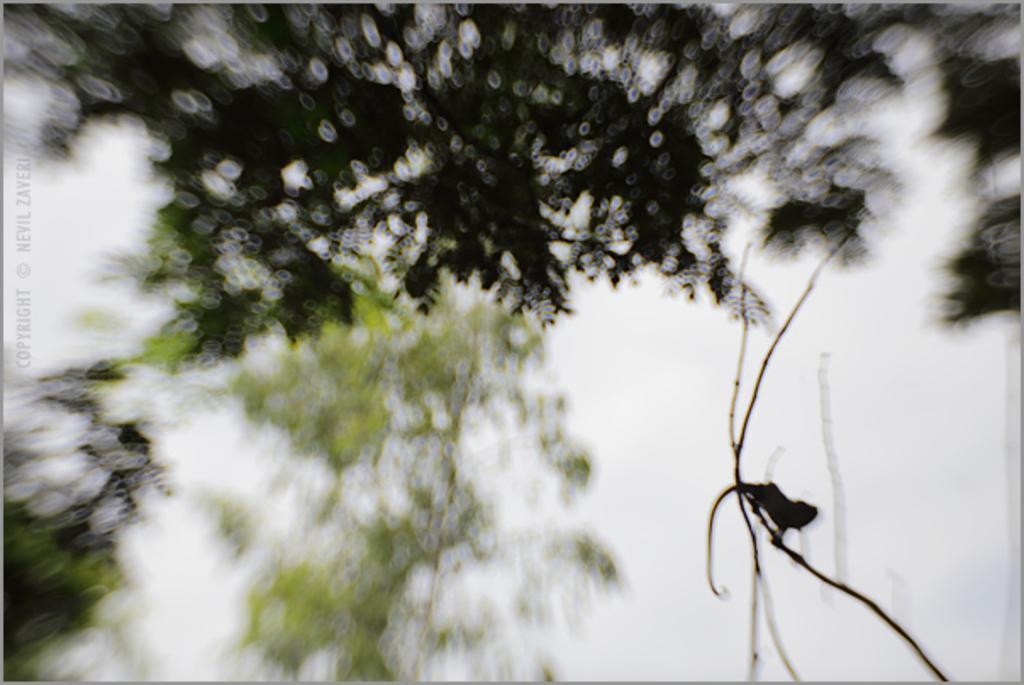Could you give a brief overview of what you see in this image? In this picture, it seems like a reptile on a stem on the right side, there are trees and sky blur, there is text on the left side. 